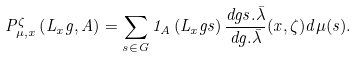Convert formula to latex. <formula><loc_0><loc_0><loc_500><loc_500>P _ { \mu , x } ^ { \zeta } \left ( L _ { x } g , A \right ) = \sum _ { s \in G } { 1 } _ { A } \left ( L _ { x } g s \right ) \frac { d g s . \bar { \lambda } } { d g . \bar { \lambda } } ( x , \zeta ) d \mu ( s ) .</formula> 